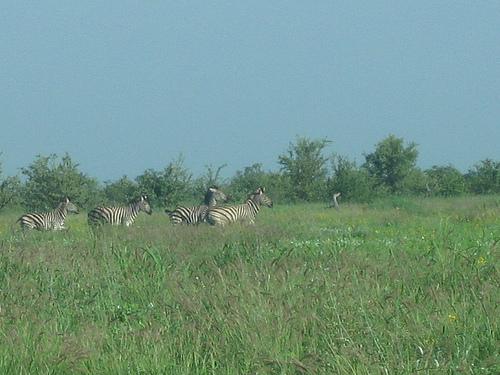Do they need rain?
Answer briefly. No. Are the zebras' feet visible in the picture?
Keep it brief. No. How many zebras?
Write a very short answer. 4. Which color is dominant?
Give a very brief answer. Green. How many blades of dry grass are there in the field?
Concise answer only. 0. What is the animal doing in the photo?
Answer briefly. Running. Are all the animals the same color?
Be succinct. Yes. What animal is this?
Short answer required. Zebra. Are the trees tall?
Give a very brief answer. No. Where is the giraffe?
Be succinct. On field. What are these animal?
Give a very brief answer. Zebras. Is this outer space?
Answer briefly. No. 